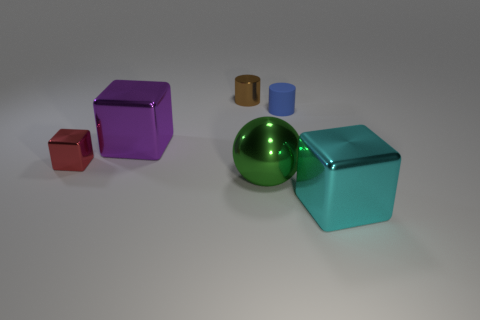There is a tiny metal object that is to the left of the small brown metal thing; is its shape the same as the cyan thing?
Keep it short and to the point. Yes. What number of tiny brown cylinders are the same material as the small red block?
Give a very brief answer. 1. What number of objects are big metal cubes that are on the left side of the brown cylinder or small rubber cylinders?
Offer a very short reply. 2. How big is the red metallic block?
Your answer should be very brief. Small. There is a tiny cylinder in front of the tiny shiny object behind the red metal block; what is its material?
Offer a terse response. Rubber. There is a shiny object to the right of the blue rubber object; is it the same size as the small red metallic object?
Provide a short and direct response. No. How many objects are either big blocks in front of the large purple thing or big objects that are behind the tiny red object?
Provide a succinct answer. 2. Is the tiny metallic cube the same color as the small shiny cylinder?
Make the answer very short. No. Are there fewer purple metallic blocks that are in front of the big purple metal object than tiny blue objects to the left of the brown cylinder?
Keep it short and to the point. No. Do the red block and the green object have the same material?
Your answer should be compact. Yes. 